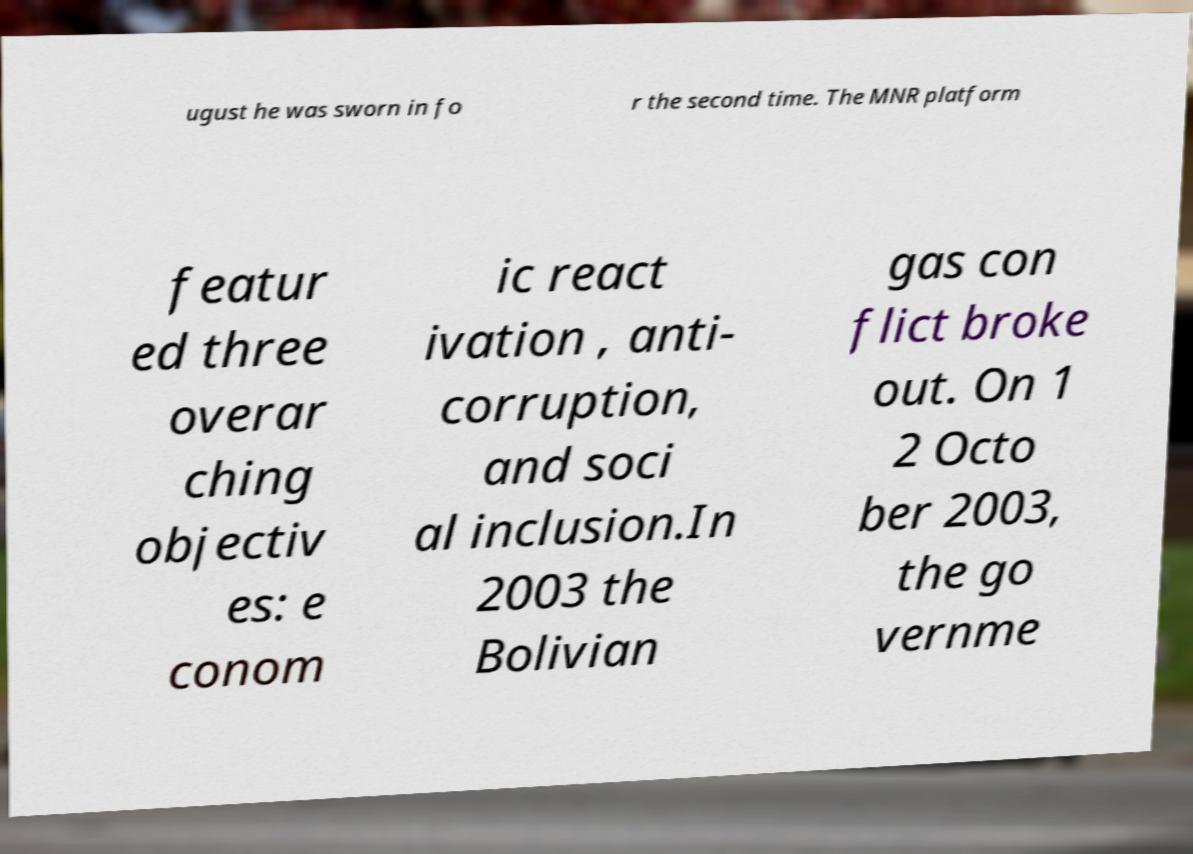Can you read and provide the text displayed in the image?This photo seems to have some interesting text. Can you extract and type it out for me? ugust he was sworn in fo r the second time. The MNR platform featur ed three overar ching objectiv es: e conom ic react ivation , anti- corruption, and soci al inclusion.In 2003 the Bolivian gas con flict broke out. On 1 2 Octo ber 2003, the go vernme 